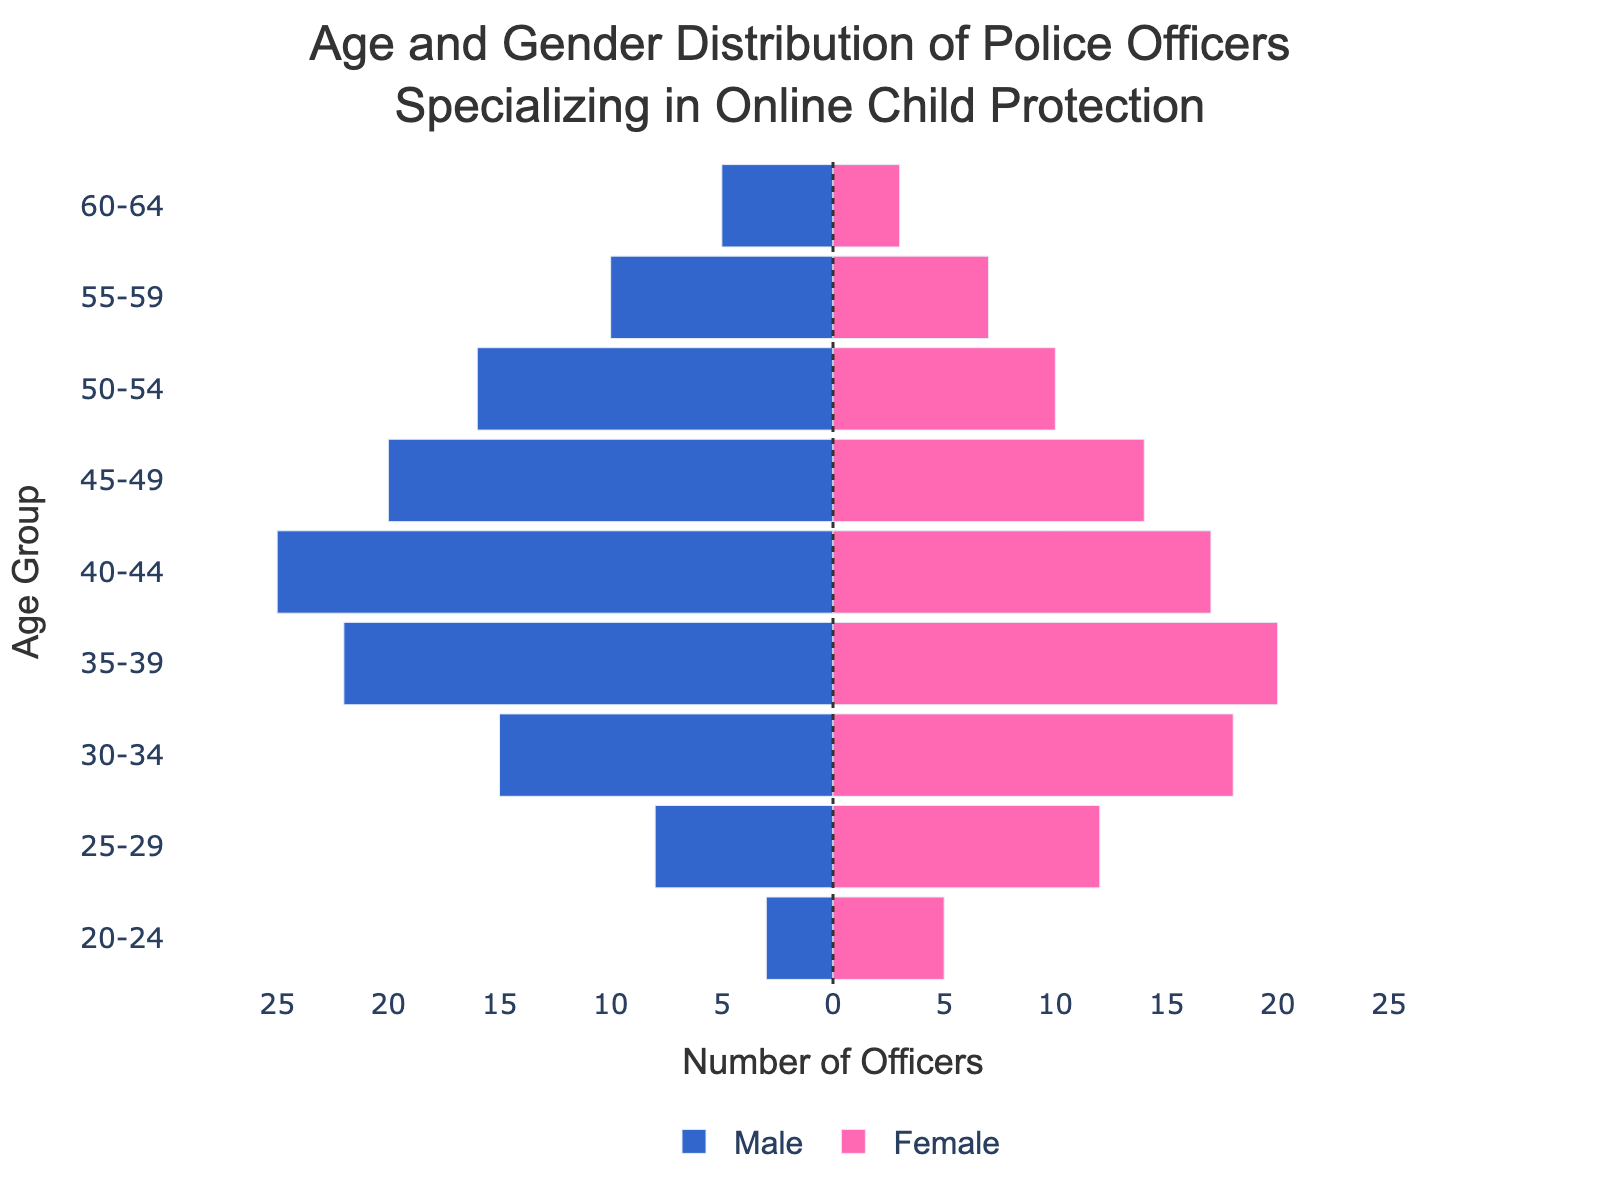What is the age group with the highest number of female police officers? To find this, look at the pink bars (female) and identify which bar extends the furthest to the right. The 30-34 age group has the longest pink bar, indicating it has the highest number of female police officers at 18.
Answer: 30-34 How many total police officers are there in the 40-44 age group? Sum the number of male and female police officers in the 40-44 age group. There are 25 male officers and 17 female officers, so the total is 25 + 17 = 42.
Answer: 42 Which gender has a higher number in the 50-54 age group? Compare the lengths of the blue and pink bars for the 50-54 age group. The blue bar (male) is longer, indicating that there are more male officers (16) compared to female officers (10).
Answer: Male What is the difference in the number of male and female police officers in the 35-39 age group? Subtract the number of female officers from the number of male officers in the 35-39 age group. There are 22 male and 20 female officers, so the difference is 22 - 20 = 2.
Answer: 2 In the 55-59 age group, what is the combined total of male and female officers? Add the number of male and female officers in the 55-59 age group. There are 10 male officers and 7 female officers, so the combined total is 10 + 7 = 17.
Answer: 17 Which age group has more female than male officers? Identify the age groups where the pink bar is longer than the blue bar. The age groups with more female officers are 20-24 and 25-29.
Answer: 20-24, 25-29 Across all age groups, which gender is predominantly more represented in the distribution? Observe the lengths of the bars overall. The blue bars (males) are generally longer across most age groups, indicating that males are predominantly more represented.
Answer: Male How many police officers are aged 60-64 in total? Add the number of male and female officers in the 60-64 age group. There are 5 male officers and 3 female officers, so the total is 5 + 3 = 8.
Answer: 8 